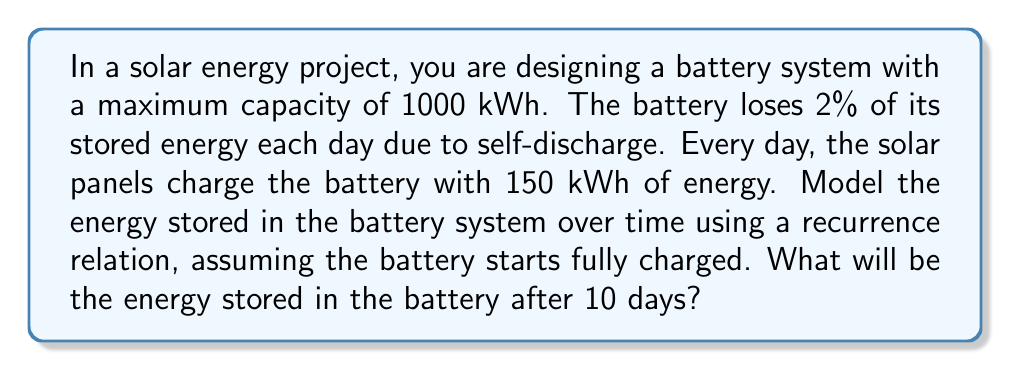Provide a solution to this math problem. Let's approach this step-by-step:

1) Let $E_n$ represent the energy stored in the battery on day $n$.

2) The initial condition is $E_0 = 1000$ kWh (fully charged).

3) Each day, the battery:
   - Loses 2% of its current charge
   - Gains 150 kWh from solar panels

4) We can express this as a recurrence relation:

   $E_{n+1} = 0.98E_n + 150$

   where $0.98E_n$ represents 98% of the previous day's energy (after 2% loss), and 150 is the daily solar input.

5) To find $E_{10}$, we need to iterate this relation 10 times:

   $E_1 = 0.98(1000) + 150 = 980 + 150 = 1130$
   $E_2 = 0.98(1130) + 150 = 1107.4 + 150 = 1257.4$
   $E_3 = 0.98(1257.4) + 150 = 1232.252 + 150 = 1382.252$
   ...

6) Continuing this process (or using a computer to iterate), we find:

   $E_{10} = 1491.550578$ kWh

7) However, remember that the battery has a maximum capacity of 1000 kWh. This means that after day 1, the battery would be at full capacity, and any excess energy would be unused.

8) Therefore, the actual recurrence relation should be:

   $E_{n+1} = \min(0.98E_n + 150, 1000)$

9) Using this corrected relation, we find that $E_n = 1000$ for all $n \geq 1$.
Answer: The energy stored in the battery after 10 days will be 1000 kWh. 